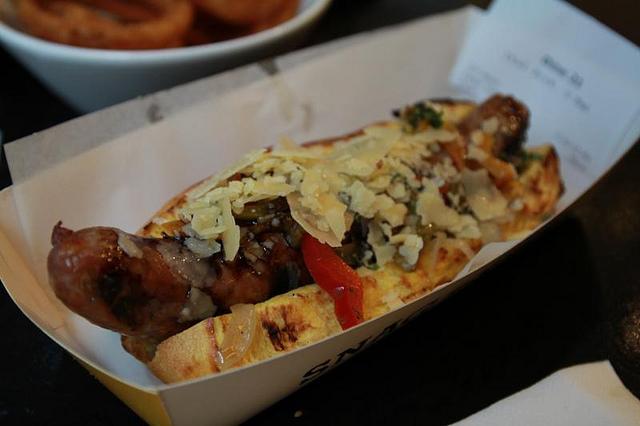Is there ketchup on this?
Concise answer only. No. Is this a healthy meal?
Answer briefly. No. What type of food is being served?
Short answer required. Hot dog. Has anyone taken a bite of this yet?
Give a very brief answer. No. What is present?
Be succinct. Hot dog. 